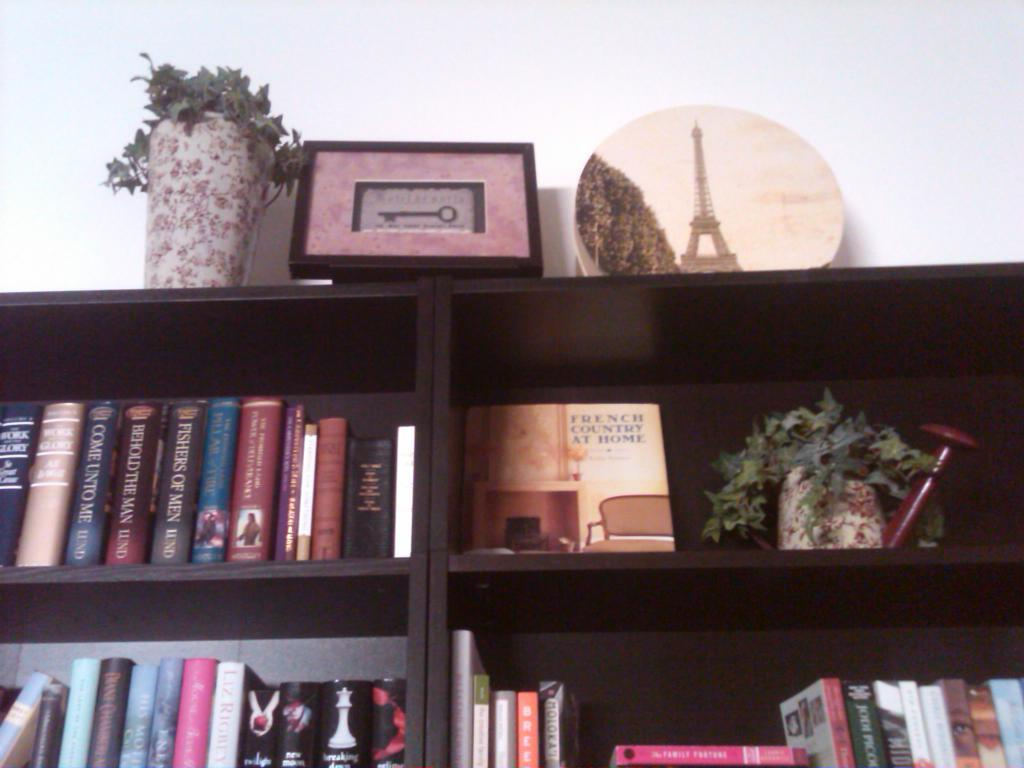Provide a one-sentence caption for the provided image. A wooden bookshelf with a vase on top and a plate picture of Eiffel tower. 